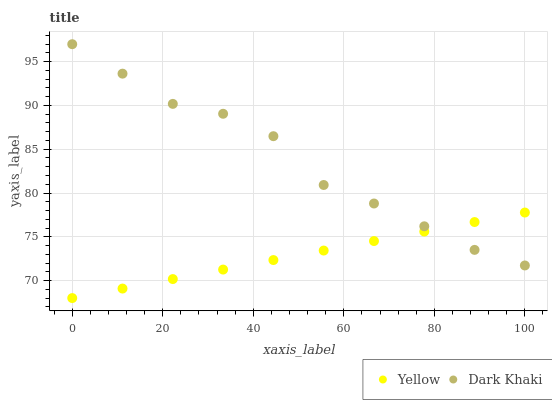Does Yellow have the minimum area under the curve?
Answer yes or no. Yes. Does Dark Khaki have the maximum area under the curve?
Answer yes or no. Yes. Does Yellow have the maximum area under the curve?
Answer yes or no. No. Is Yellow the smoothest?
Answer yes or no. Yes. Is Dark Khaki the roughest?
Answer yes or no. Yes. Is Yellow the roughest?
Answer yes or no. No. Does Yellow have the lowest value?
Answer yes or no. Yes. Does Dark Khaki have the highest value?
Answer yes or no. Yes. Does Yellow have the highest value?
Answer yes or no. No. Does Yellow intersect Dark Khaki?
Answer yes or no. Yes. Is Yellow less than Dark Khaki?
Answer yes or no. No. Is Yellow greater than Dark Khaki?
Answer yes or no. No. 